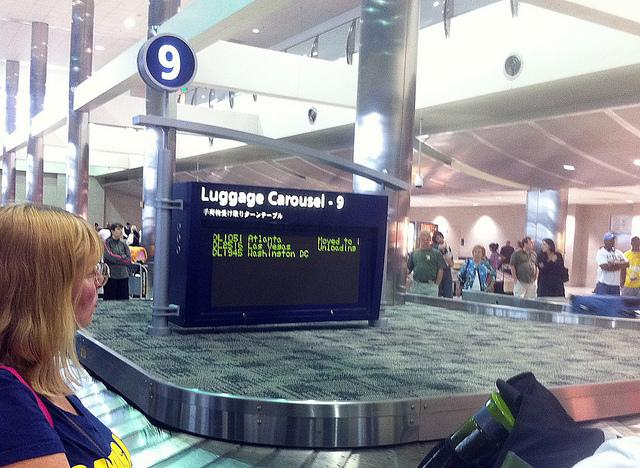What country's cities are listed on the information board?

Choices:
A) mexico
B) united states
C) england
D) brazil united states 